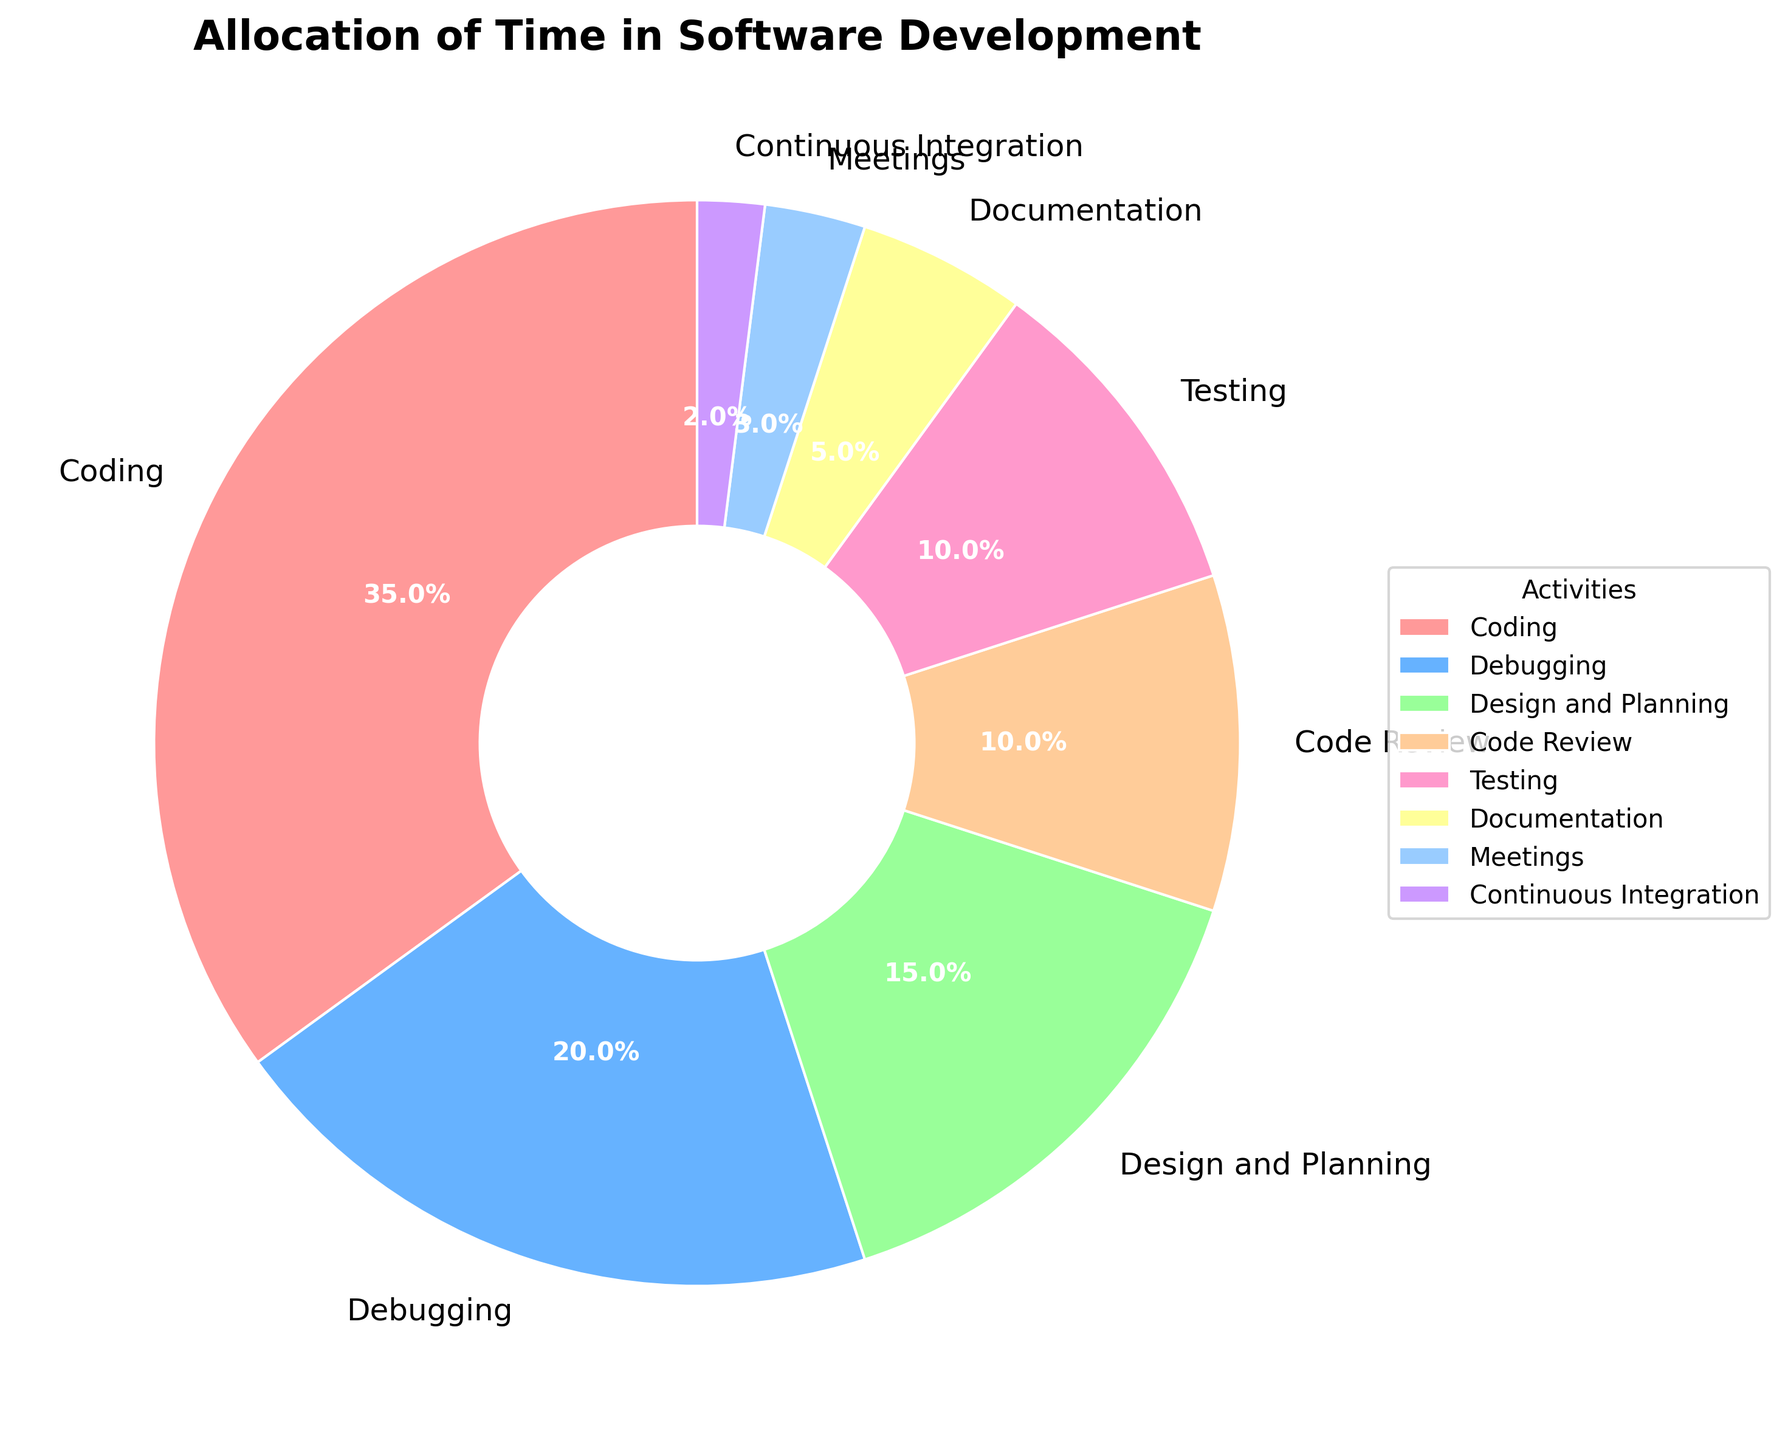What's the second most time-consuming activity? To determine the second most time-consuming activity, look at the percentages and find the largest one after the top value. Coding takes 35%, which is the highest. Debugging at 20% is the next highest.
Answer: Debugging What is the combined percentage of time spent on Coding and Testing? Sum the percentages of Coding and Testing. Coding is 35% and Testing is 10%. So, 35 + 10 = 45.
Answer: 45% Which activity takes up the least amount of time? Compare the percentages of all activities and find the smallest one. Continuous Integration has the smallest percentage at 2%.
Answer: Continuous Integration Is more time allocated to Code Review or Documentation? Compare the percentages of Code Review (10%) and Documentation (5%). Code Review is greater.
Answer: Code Review How much more time is spent on Meetings compared to Continuous Integration? Subtract the percentage of Continuous Integration (2%) from Meetings (3%). 3 - 2 = 1.
Answer: 1% What percentage of time is spent on activities other than Coding and Debugging? Subtract the combined percentage of Coding (35%) and Debugging (20%) from 100%. 100 - (35 + 20) = 45.
Answer: 45% How does the time spent on Design and Planning compare to the time spent on Code Review? Compare the percentages of Design and Planning (15%) and Code Review (10%). Design and Planning is greater.
Answer: Design and Planning What is the average percentage of time spent on Documentation, Meetings, and Continuous Integration? Sum the percentages of Documentation, Meetings, and Continuous Integration and divide by the number of activities. (5 + 3 + 2) / 3 = 10 / 3 ≈ 3.33.
Answer: 3.33% Does the time spent on Code Review and Documentation combined equal the time spent on Design and Planning? Sum the percentages of Code Review (10%) and Documentation (5%) and compare it to Design and Planning (15%). 10 + 5 = 15, which is equal to 15.
Answer: Yes What is the difference in time allocation between the most time-consuming activity and the least time-consuming activity? Subtract the percentage of Continuous Integration (2%) from Coding (35%). 35 - 2 = 33.
Answer: 33% 